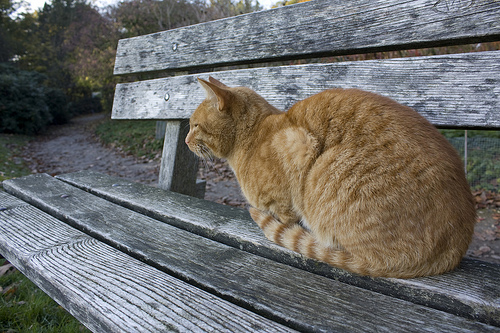How clean is the path behind the bench? The path behind the bench appears dirty, with a rough and uneven surface. 